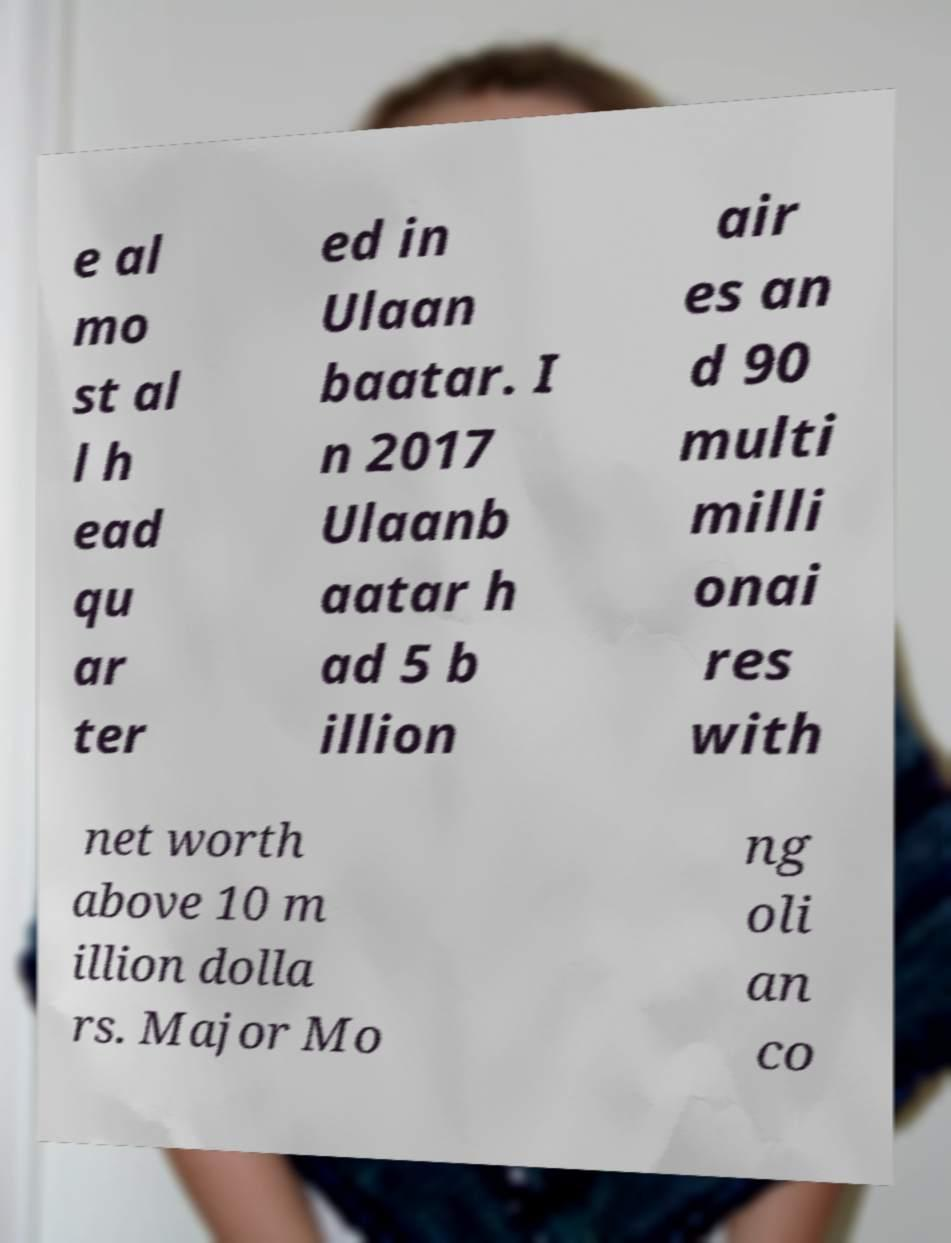I need the written content from this picture converted into text. Can you do that? e al mo st al l h ead qu ar ter ed in Ulaan baatar. I n 2017 Ulaanb aatar h ad 5 b illion air es an d 90 multi milli onai res with net worth above 10 m illion dolla rs. Major Mo ng oli an co 